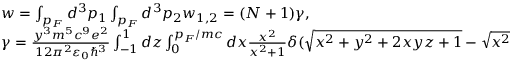Convert formula to latex. <formula><loc_0><loc_0><loc_500><loc_500>\begin{array} { l } { w = \int _ { p _ { F } } d ^ { 3 } p _ { 1 } \int _ { p _ { F } } d ^ { 3 } p _ { 2 } w _ { 1 , 2 } = ( N + 1 ) \gamma , } \\ { \gamma = \frac { y ^ { 3 } m ^ { 5 } c ^ { 9 } e ^ { 2 } } { 1 2 \pi ^ { 2 } \varepsilon _ { 0 } \hbar { ^ } { 3 } } \int _ { - 1 } ^ { 1 } d z \int _ { 0 } ^ { p _ { F } / m c } d x \frac { x ^ { 2 } } { x ^ { 2 } + 1 } \delta ( \sqrt { x ^ { 2 } + y ^ { 2 } + 2 x y z + 1 } - \sqrt { x ^ { 2 } + 1 } - 0 . 5 7 y ) , } \end{array}</formula> 